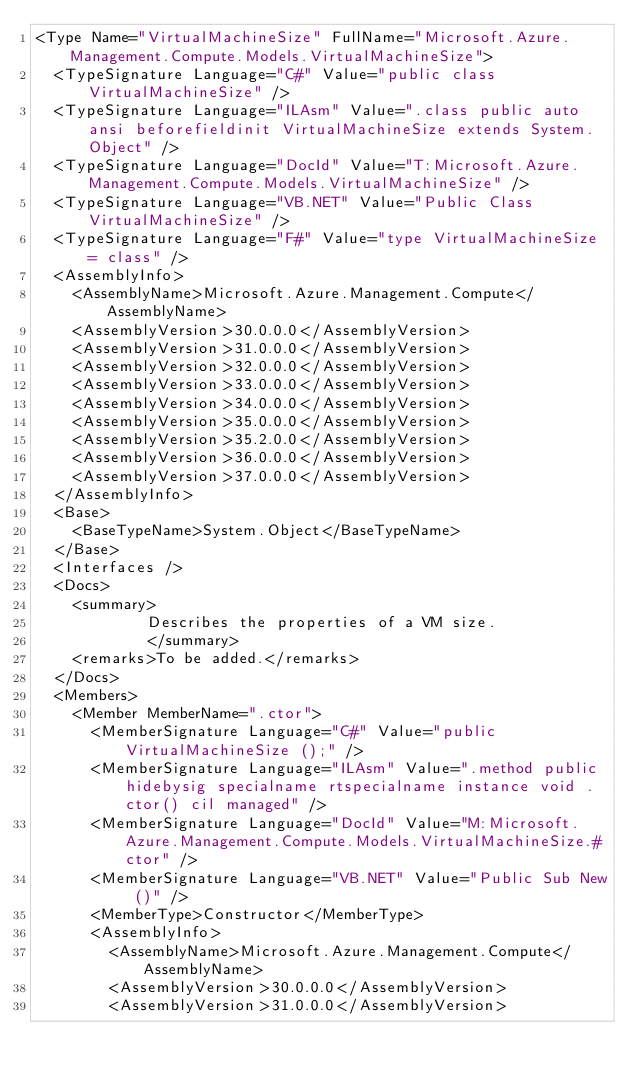<code> <loc_0><loc_0><loc_500><loc_500><_XML_><Type Name="VirtualMachineSize" FullName="Microsoft.Azure.Management.Compute.Models.VirtualMachineSize">
  <TypeSignature Language="C#" Value="public class VirtualMachineSize" />
  <TypeSignature Language="ILAsm" Value=".class public auto ansi beforefieldinit VirtualMachineSize extends System.Object" />
  <TypeSignature Language="DocId" Value="T:Microsoft.Azure.Management.Compute.Models.VirtualMachineSize" />
  <TypeSignature Language="VB.NET" Value="Public Class VirtualMachineSize" />
  <TypeSignature Language="F#" Value="type VirtualMachineSize = class" />
  <AssemblyInfo>
    <AssemblyName>Microsoft.Azure.Management.Compute</AssemblyName>
    <AssemblyVersion>30.0.0.0</AssemblyVersion>
    <AssemblyVersion>31.0.0.0</AssemblyVersion>
    <AssemblyVersion>32.0.0.0</AssemblyVersion>
    <AssemblyVersion>33.0.0.0</AssemblyVersion>
    <AssemblyVersion>34.0.0.0</AssemblyVersion>
    <AssemblyVersion>35.0.0.0</AssemblyVersion>
    <AssemblyVersion>35.2.0.0</AssemblyVersion>
    <AssemblyVersion>36.0.0.0</AssemblyVersion>
    <AssemblyVersion>37.0.0.0</AssemblyVersion>
  </AssemblyInfo>
  <Base>
    <BaseTypeName>System.Object</BaseTypeName>
  </Base>
  <Interfaces />
  <Docs>
    <summary>
            Describes the properties of a VM size.
            </summary>
    <remarks>To be added.</remarks>
  </Docs>
  <Members>
    <Member MemberName=".ctor">
      <MemberSignature Language="C#" Value="public VirtualMachineSize ();" />
      <MemberSignature Language="ILAsm" Value=".method public hidebysig specialname rtspecialname instance void .ctor() cil managed" />
      <MemberSignature Language="DocId" Value="M:Microsoft.Azure.Management.Compute.Models.VirtualMachineSize.#ctor" />
      <MemberSignature Language="VB.NET" Value="Public Sub New ()" />
      <MemberType>Constructor</MemberType>
      <AssemblyInfo>
        <AssemblyName>Microsoft.Azure.Management.Compute</AssemblyName>
        <AssemblyVersion>30.0.0.0</AssemblyVersion>
        <AssemblyVersion>31.0.0.0</AssemblyVersion></code> 